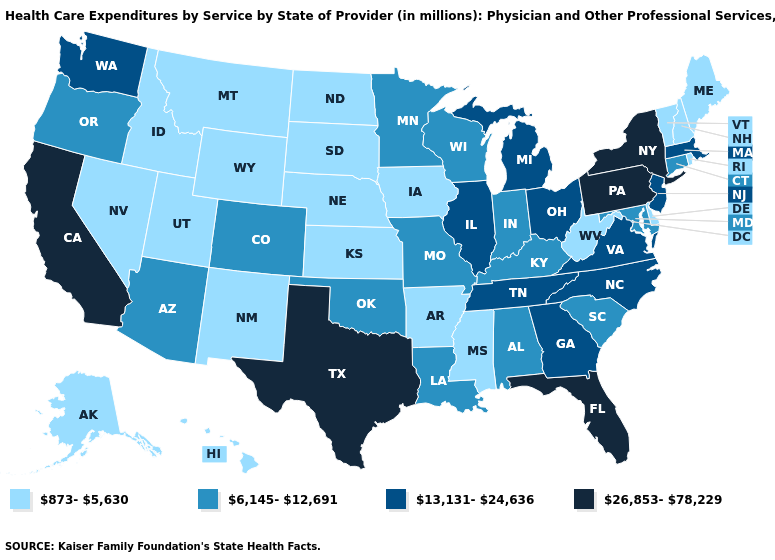Does Utah have the lowest value in the USA?
Write a very short answer. Yes. What is the highest value in the West ?
Answer briefly. 26,853-78,229. Name the states that have a value in the range 26,853-78,229?
Quick response, please. California, Florida, New York, Pennsylvania, Texas. Among the states that border Kansas , does Nebraska have the highest value?
Short answer required. No. What is the lowest value in the USA?
Concise answer only. 873-5,630. Name the states that have a value in the range 13,131-24,636?
Give a very brief answer. Georgia, Illinois, Massachusetts, Michigan, New Jersey, North Carolina, Ohio, Tennessee, Virginia, Washington. Does Tennessee have a higher value than Hawaii?
Be succinct. Yes. Among the states that border Texas , does New Mexico have the highest value?
Be succinct. No. Among the states that border Wisconsin , which have the lowest value?
Short answer required. Iowa. Does Michigan have the highest value in the MidWest?
Concise answer only. Yes. Which states have the highest value in the USA?
Short answer required. California, Florida, New York, Pennsylvania, Texas. Name the states that have a value in the range 13,131-24,636?
Be succinct. Georgia, Illinois, Massachusetts, Michigan, New Jersey, North Carolina, Ohio, Tennessee, Virginia, Washington. What is the lowest value in states that border Utah?
Keep it brief. 873-5,630. Does Florida have the same value as Texas?
Concise answer only. Yes. What is the highest value in the MidWest ?
Short answer required. 13,131-24,636. 